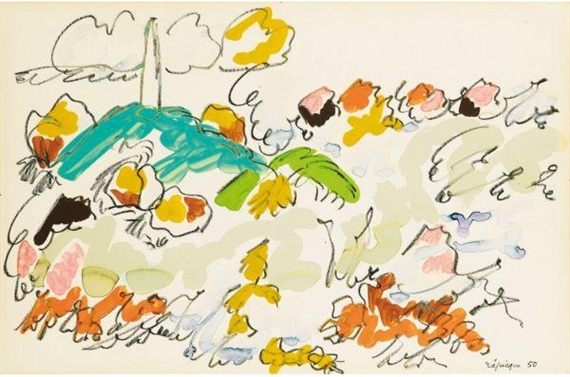What are the key elements in this picture? The artwork displayed is a burst of vivid colors and lively abstract forms, embodying a sense of freedom and spontaneity typical of abstract expressionist art. This image plays with an array of vibrant colors including yellow, orange, blue, and green, set against a soft white background with hints of gray, suggestive of a cloudy sky. Key features interpreted in this scene might be a stylized blue bird and a tropical green palm tree, surrounded by various fluid shapes and strokes that could evoke flowers and foliage. There's an engaging dynamic between the elements and the space, making the piece vibrant and open to interpretation, thus inviting viewers to find their own meaning or emotional resonance within the chaos of colors and forms. 